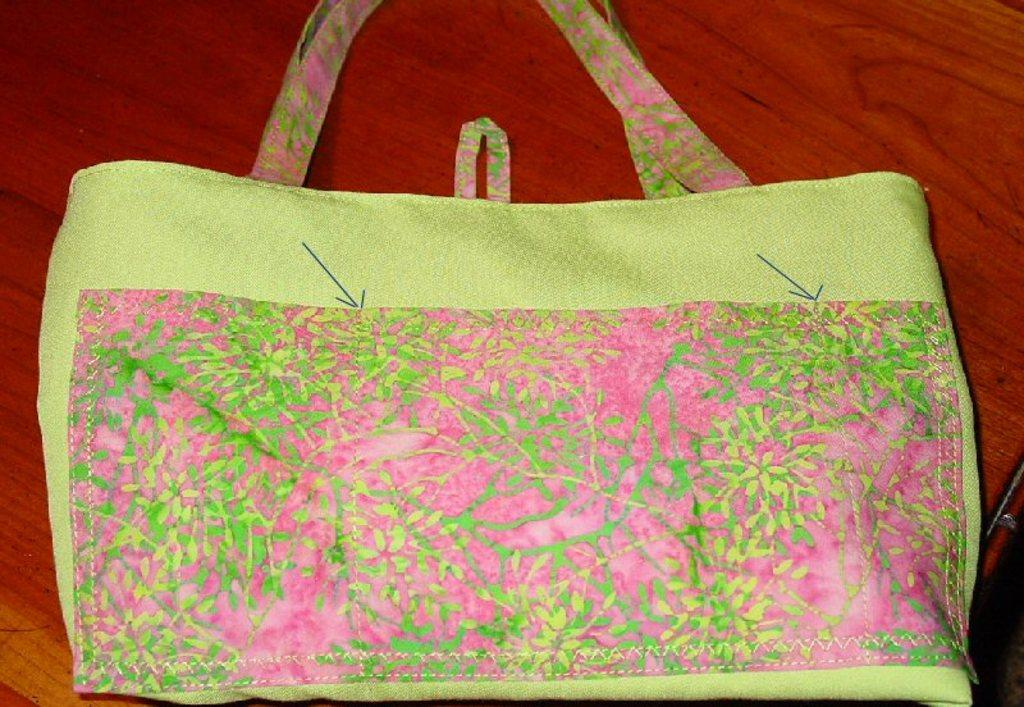What color is the handbag in the image? The handbag in the image is green. Where is the handbag located in the image? The handbag is placed on a white table. What type of lace can be seen on the handbag in the image? There is no lace present on the handbag in the image. What sound does the bell make when it's rung in the image? There is no bell present in the image. 